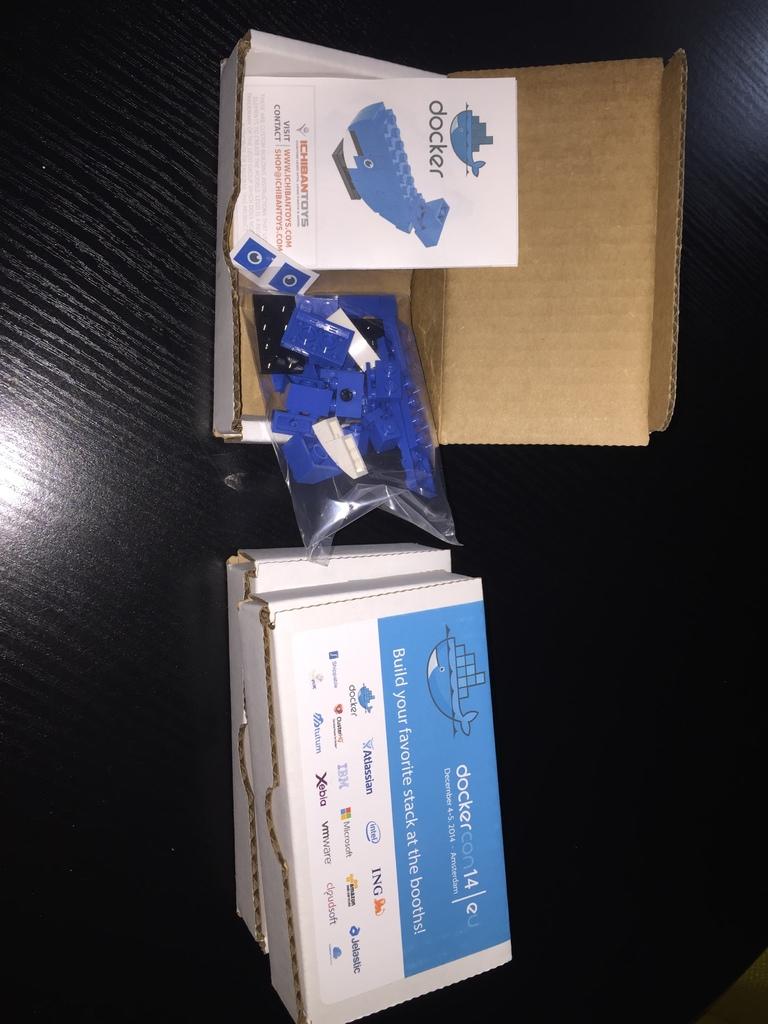What is the name of one of the brands on the box?
Your answer should be very brief. Docker. What is the name of this toy?
Your answer should be compact. Docker. 